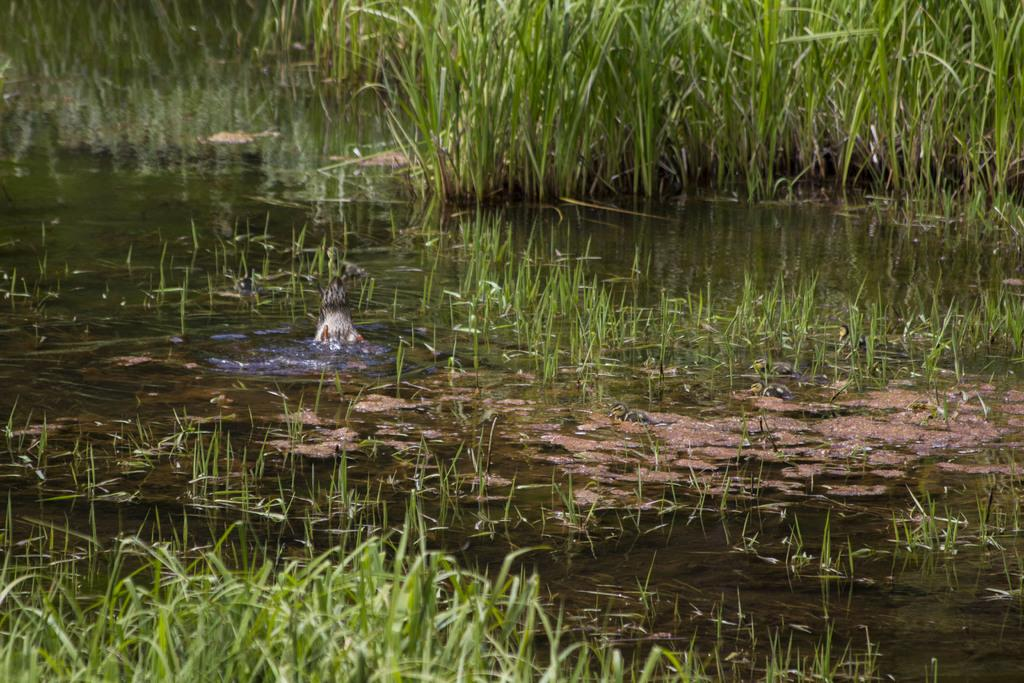What type of animal can be seen in the image? There is an aquatic animal in the image. Where is the aquatic animal located? The aquatic animal is in the water. What color is the grass in the background? The grass in the background is green. What type of metal can be seen in the image? There is no metal present in the image; it features an aquatic animal in the water with green grass in the background. 